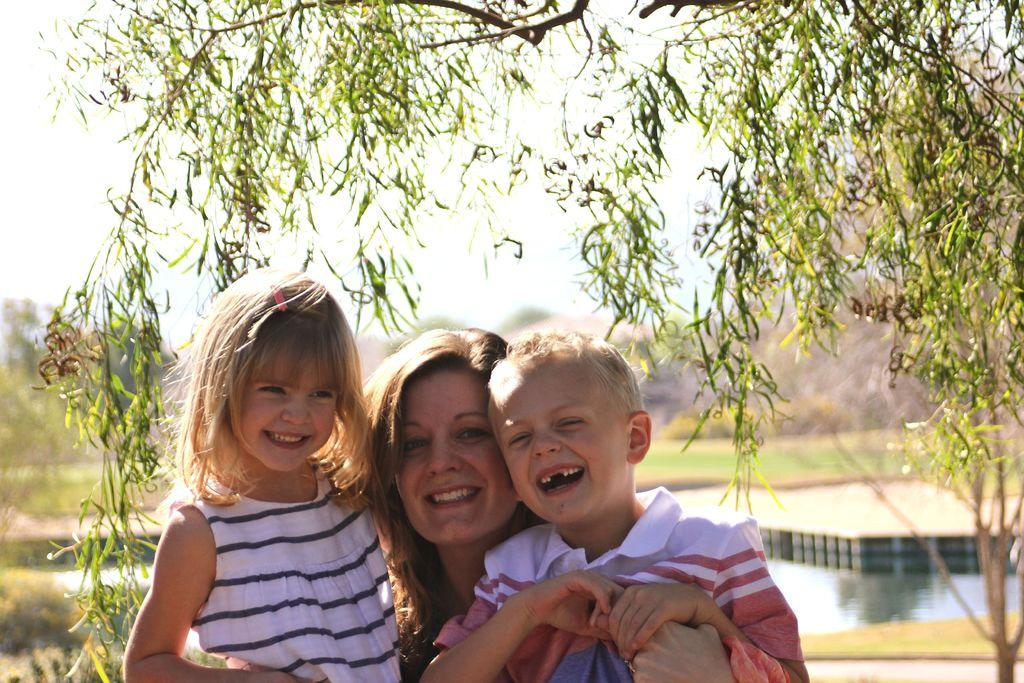How many people are in the image? There are three persons in the image. What type of terrain is visible in the image? There is grassy land in the image. What other natural elements can be seen in the image? There are many trees and a lake in the image. What is visible in the background of the image? The sky is visible in the image. What type of metal is used to create the invention in the image? There is no invention or metal present in the image. What color is the cap worn by the person in the image? There is no cap worn by any person in the image. 